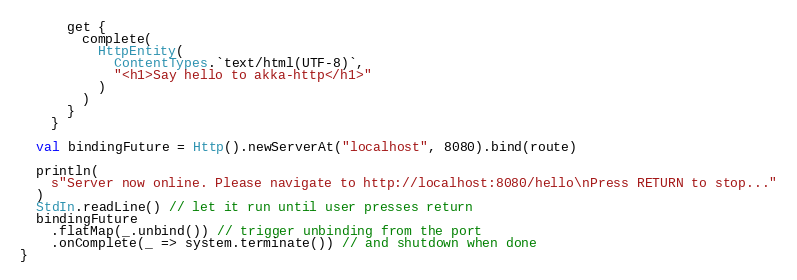<code> <loc_0><loc_0><loc_500><loc_500><_Scala_>      get {
        complete(
          HttpEntity(
            ContentTypes.`text/html(UTF-8)`,
            "<h1>Say hello to akka-http</h1>"
          )
        )
      }
    }

  val bindingFuture = Http().newServerAt("localhost", 8080).bind(route)

  println(
    s"Server now online. Please navigate to http://localhost:8080/hello\nPress RETURN to stop..."
  )
  StdIn.readLine() // let it run until user presses return
  bindingFuture
    .flatMap(_.unbind()) // trigger unbinding from the port
    .onComplete(_ => system.terminate()) // and shutdown when done
}
</code> 